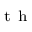<formula> <loc_0><loc_0><loc_500><loc_500>^ { t h }</formula> 